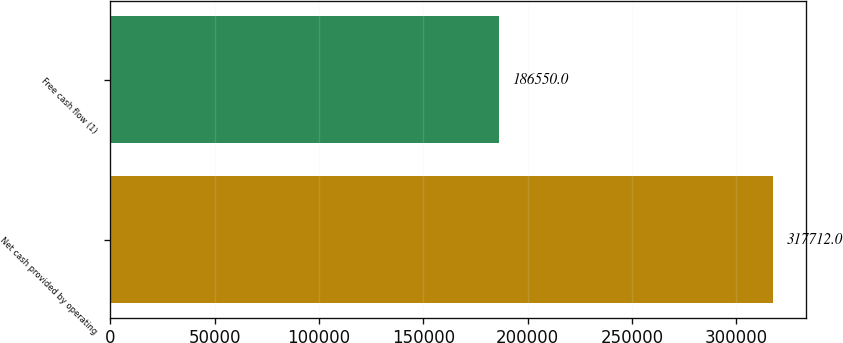<chart> <loc_0><loc_0><loc_500><loc_500><bar_chart><fcel>Net cash provided by operating<fcel>Free cash flow (1)<nl><fcel>317712<fcel>186550<nl></chart> 